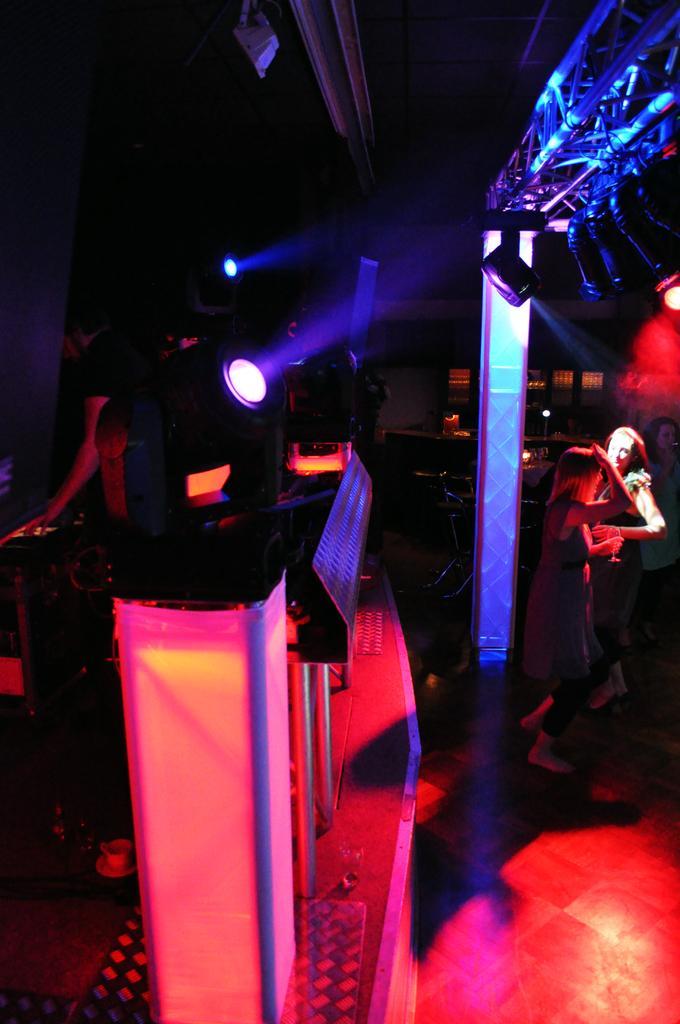In one or two sentences, can you explain what this image depicts? In this image, we can see two persons standing and wearing clothes. There is a metal frame on the right side of the image. There are lights in the middle of the image. There are poles at the bottom of the image. 